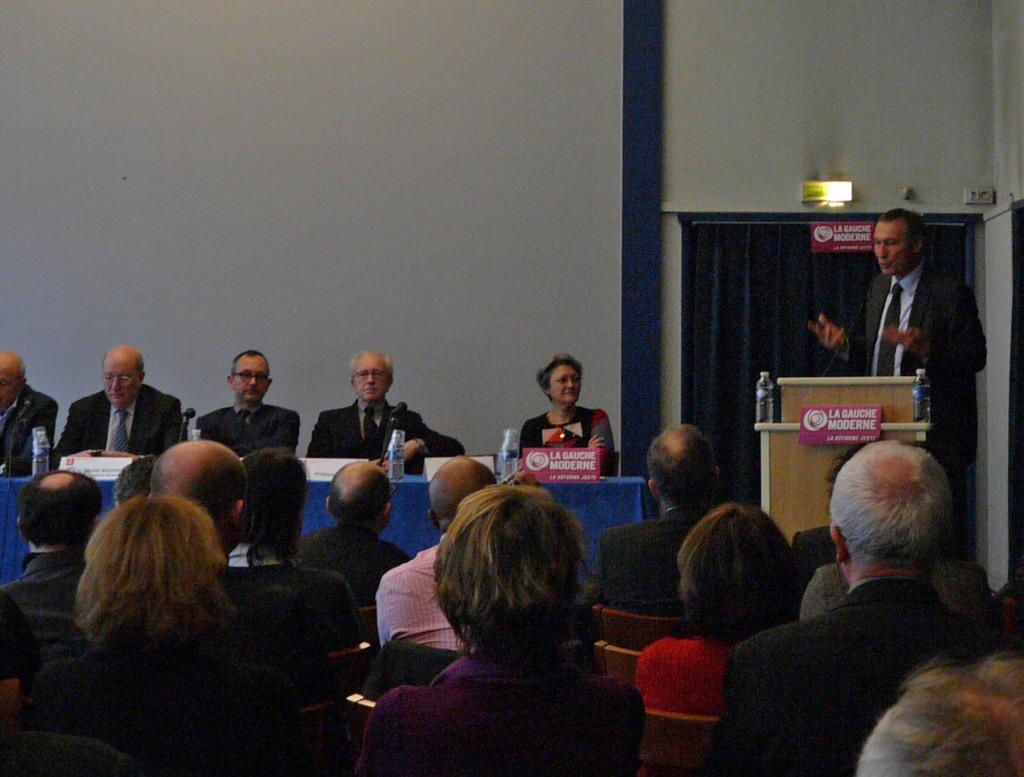Describe this image in one or two sentences. People are sitting. A person is standing at the right back wearing a suit. There is a microphone on a table and there are water bottles. People are seated at the back and there is a blue table on which there are bottles and name plates. There is a curtain and boards at the right back. 